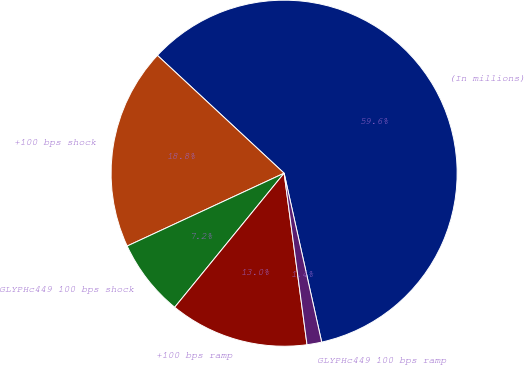Convert chart to OTSL. <chart><loc_0><loc_0><loc_500><loc_500><pie_chart><fcel>(In millions)<fcel>+100 bps shock<fcel>GLYPHc449 100 bps shock<fcel>+100 bps ramp<fcel>GLYPHc449 100 bps ramp<nl><fcel>59.6%<fcel>18.84%<fcel>7.19%<fcel>13.01%<fcel>1.37%<nl></chart> 